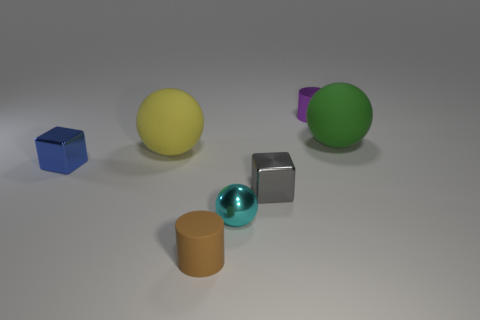Add 1 purple rubber spheres. How many objects exist? 8 Subtract all cylinders. How many objects are left? 5 Subtract all big brown metallic cylinders. Subtract all blue cubes. How many objects are left? 6 Add 2 metallic objects. How many metallic objects are left? 6 Add 6 cyan shiny objects. How many cyan shiny objects exist? 7 Subtract 0 green cubes. How many objects are left? 7 